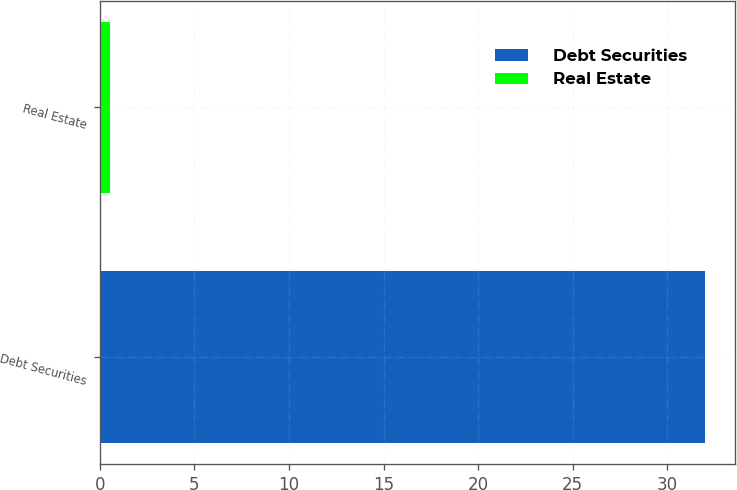<chart> <loc_0><loc_0><loc_500><loc_500><bar_chart><fcel>Debt Securities<fcel>Real Estate<nl><fcel>32<fcel>0.56<nl></chart> 